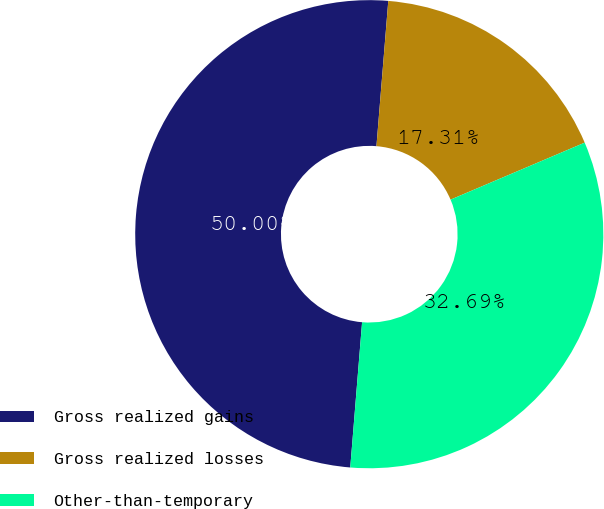Convert chart. <chart><loc_0><loc_0><loc_500><loc_500><pie_chart><fcel>Gross realized gains<fcel>Gross realized losses<fcel>Other-than-temporary<nl><fcel>50.0%<fcel>17.31%<fcel>32.69%<nl></chart> 